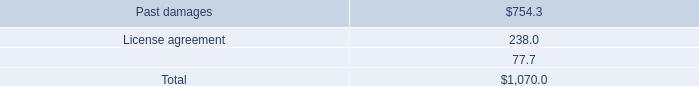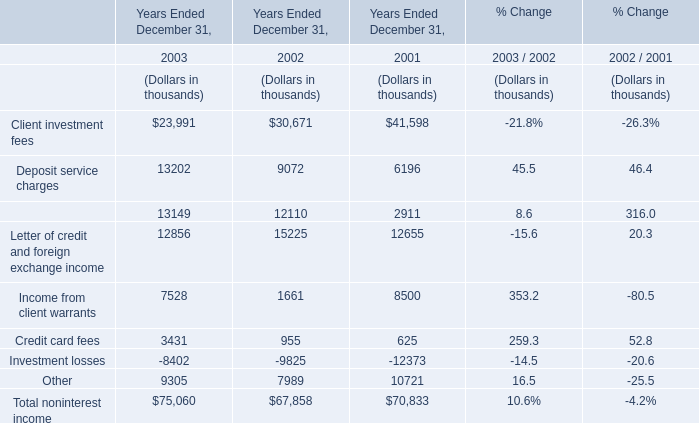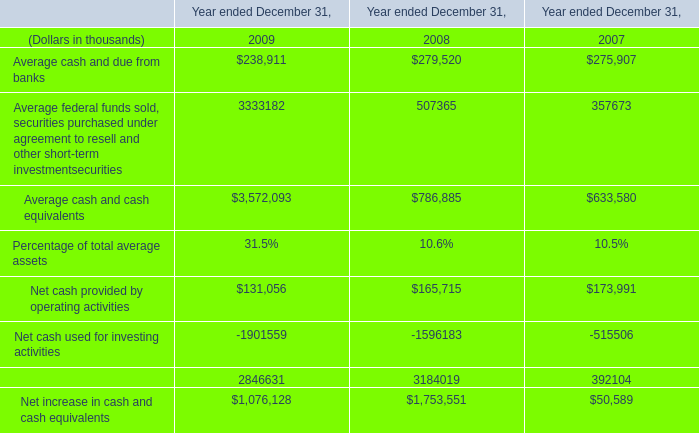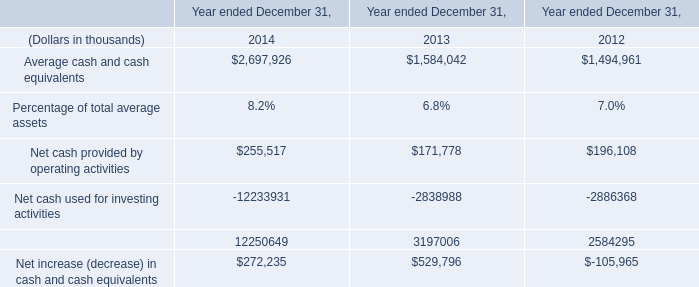If Corporate finance fees develops with the same increasing rate in 2003, what will it reach in 2004? (in thousand) 
Computations: (13149 * (1 + ((13149 - 12110) / 12110)))
Answer: 14277.14294. 